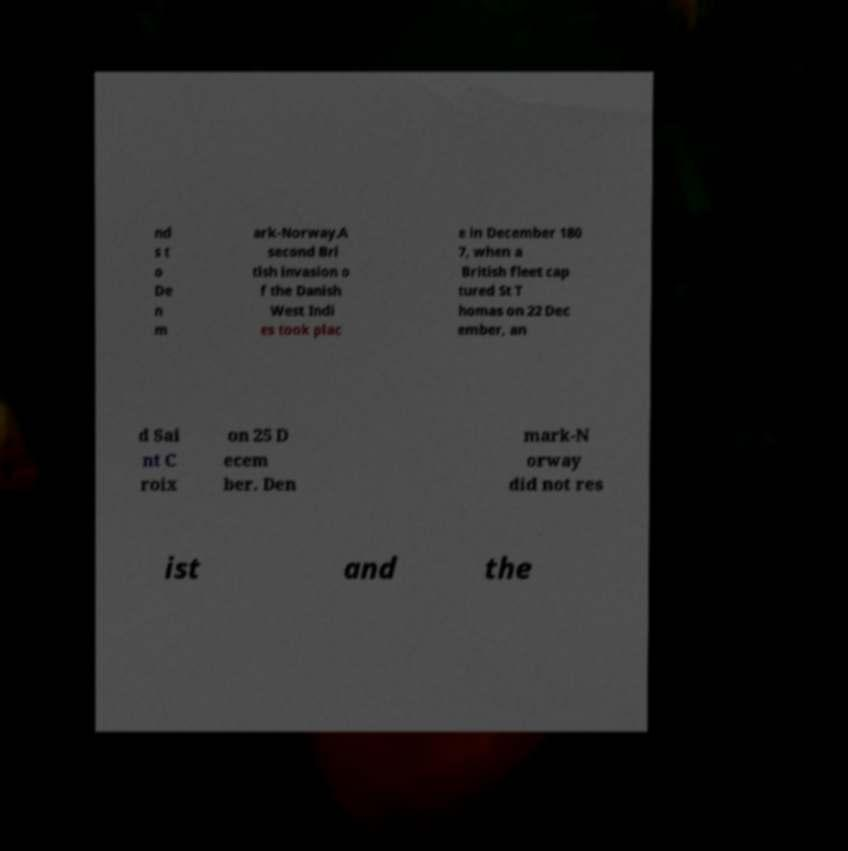What messages or text are displayed in this image? I need them in a readable, typed format. nd s t o De n m ark-Norway.A second Bri tish invasion o f the Danish West Indi es took plac e in December 180 7, when a British fleet cap tured St T homas on 22 Dec ember, an d Sai nt C roix on 25 D ecem ber. Den mark-N orway did not res ist and the 